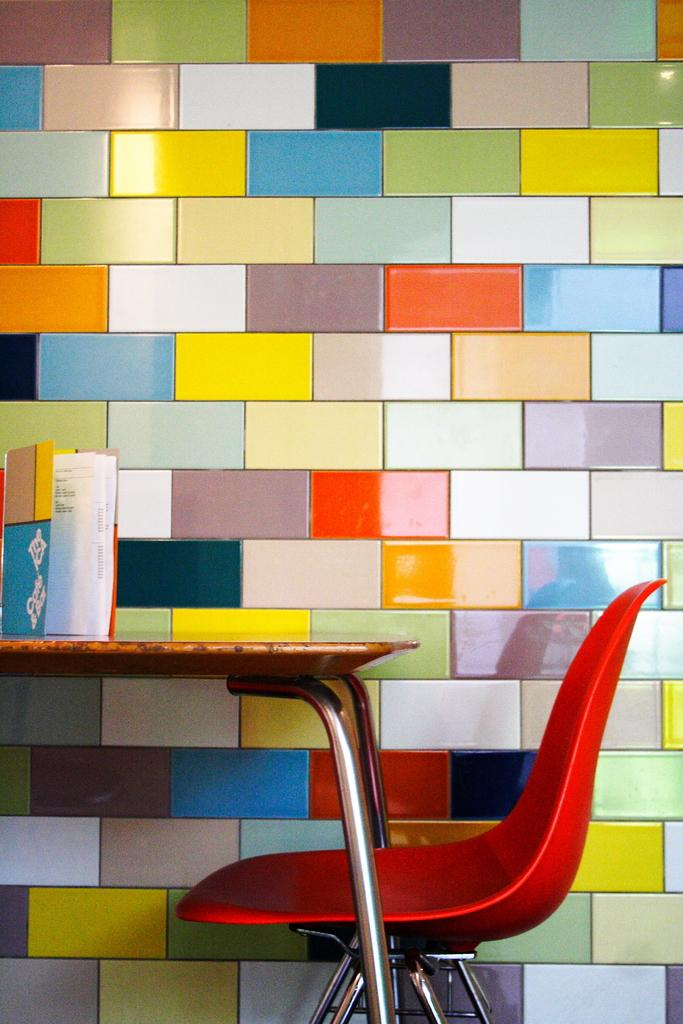What type of furniture is present in the image? There is a chair in the image. What object can be seen on a table in the image? There is a book on a table in the image. What can be observed about the wall in the image? There are multiple colors on the wall in the image. Can you tell me how many donkeys are present in the image? There are no donkeys present in the image. What type of breakfast is being served in the image? There is no breakfast visible in the image. 